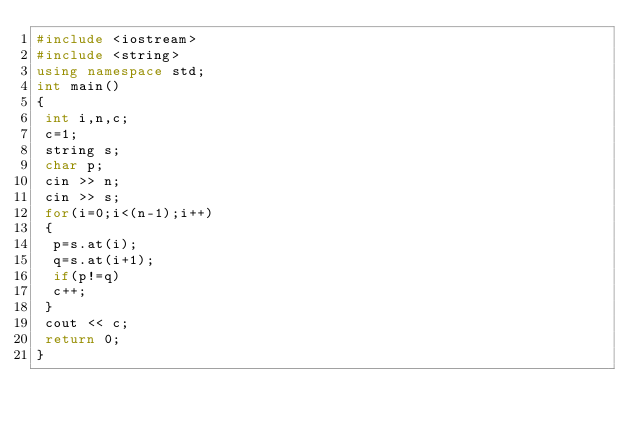Convert code to text. <code><loc_0><loc_0><loc_500><loc_500><_C++_>#include <iostream>
#include <string>
using namespace std;
int main()
{
 int i,n,c;
 c=1;
 string s;
 char p;
 cin >> n;
 cin >> s;
 for(i=0;i<(n-1);i++)
 {
  p=s.at(i);
  q=s.at(i+1);
  if(p!=q)
  c++;
 }
 cout << c;
 return 0;
}</code> 